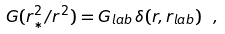Convert formula to latex. <formula><loc_0><loc_0><loc_500><loc_500>G ( r _ { * } ^ { 2 } / r ^ { 2 } ) = G _ { l a b } \, \delta ( r , r _ { l a b } ) \ ,</formula> 